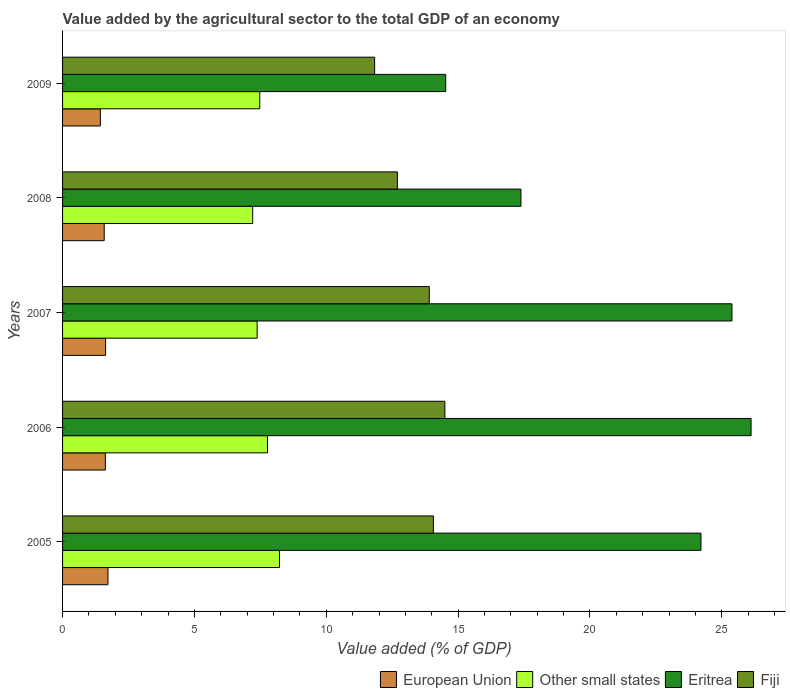What is the value added by the agricultural sector to the total GDP in Fiji in 2005?
Your response must be concise. 14.06. Across all years, what is the maximum value added by the agricultural sector to the total GDP in Eritrea?
Offer a terse response. 26.11. Across all years, what is the minimum value added by the agricultural sector to the total GDP in Eritrea?
Provide a short and direct response. 14.53. In which year was the value added by the agricultural sector to the total GDP in Other small states maximum?
Keep it short and to the point. 2005. What is the total value added by the agricultural sector to the total GDP in Fiji in the graph?
Offer a terse response. 67. What is the difference between the value added by the agricultural sector to the total GDP in Eritrea in 2007 and that in 2008?
Offer a terse response. 8. What is the difference between the value added by the agricultural sector to the total GDP in Fiji in 2006 and the value added by the agricultural sector to the total GDP in Eritrea in 2008?
Offer a terse response. -2.88. What is the average value added by the agricultural sector to the total GDP in Other small states per year?
Your response must be concise. 7.61. In the year 2006, what is the difference between the value added by the agricultural sector to the total GDP in Fiji and value added by the agricultural sector to the total GDP in Eritrea?
Provide a short and direct response. -11.61. What is the ratio of the value added by the agricultural sector to the total GDP in Other small states in 2006 to that in 2008?
Provide a succinct answer. 1.08. What is the difference between the highest and the second highest value added by the agricultural sector to the total GDP in Eritrea?
Offer a very short reply. 0.73. What is the difference between the highest and the lowest value added by the agricultural sector to the total GDP in Fiji?
Your answer should be compact. 2.66. In how many years, is the value added by the agricultural sector to the total GDP in European Union greater than the average value added by the agricultural sector to the total GDP in European Union taken over all years?
Provide a short and direct response. 3. Is the sum of the value added by the agricultural sector to the total GDP in Fiji in 2008 and 2009 greater than the maximum value added by the agricultural sector to the total GDP in European Union across all years?
Offer a very short reply. Yes. What does the 2nd bar from the bottom in 2007 represents?
Make the answer very short. Other small states. Is it the case that in every year, the sum of the value added by the agricultural sector to the total GDP in European Union and value added by the agricultural sector to the total GDP in Other small states is greater than the value added by the agricultural sector to the total GDP in Fiji?
Offer a terse response. No. Are all the bars in the graph horizontal?
Provide a succinct answer. Yes. Does the graph contain any zero values?
Make the answer very short. No. Where does the legend appear in the graph?
Keep it short and to the point. Bottom right. How many legend labels are there?
Your answer should be very brief. 4. What is the title of the graph?
Keep it short and to the point. Value added by the agricultural sector to the total GDP of an economy. What is the label or title of the X-axis?
Your answer should be very brief. Value added (% of GDP). What is the label or title of the Y-axis?
Keep it short and to the point. Years. What is the Value added (% of GDP) in European Union in 2005?
Your answer should be compact. 1.72. What is the Value added (% of GDP) in Other small states in 2005?
Your answer should be very brief. 8.23. What is the Value added (% of GDP) in Eritrea in 2005?
Your answer should be compact. 24.21. What is the Value added (% of GDP) in Fiji in 2005?
Your answer should be very brief. 14.06. What is the Value added (% of GDP) in European Union in 2006?
Give a very brief answer. 1.62. What is the Value added (% of GDP) of Other small states in 2006?
Give a very brief answer. 7.77. What is the Value added (% of GDP) of Eritrea in 2006?
Your answer should be compact. 26.11. What is the Value added (% of GDP) in Fiji in 2006?
Your answer should be very brief. 14.5. What is the Value added (% of GDP) in European Union in 2007?
Offer a very short reply. 1.63. What is the Value added (% of GDP) of Other small states in 2007?
Offer a very short reply. 7.38. What is the Value added (% of GDP) of Eritrea in 2007?
Make the answer very short. 25.38. What is the Value added (% of GDP) in Fiji in 2007?
Give a very brief answer. 13.91. What is the Value added (% of GDP) of European Union in 2008?
Your response must be concise. 1.58. What is the Value added (% of GDP) of Other small states in 2008?
Keep it short and to the point. 7.21. What is the Value added (% of GDP) of Eritrea in 2008?
Ensure brevity in your answer.  17.38. What is the Value added (% of GDP) in Fiji in 2008?
Your response must be concise. 12.7. What is the Value added (% of GDP) in European Union in 2009?
Make the answer very short. 1.43. What is the Value added (% of GDP) in Other small states in 2009?
Offer a terse response. 7.48. What is the Value added (% of GDP) of Eritrea in 2009?
Your answer should be compact. 14.53. What is the Value added (% of GDP) of Fiji in 2009?
Your answer should be compact. 11.83. Across all years, what is the maximum Value added (% of GDP) of European Union?
Provide a succinct answer. 1.72. Across all years, what is the maximum Value added (% of GDP) of Other small states?
Provide a short and direct response. 8.23. Across all years, what is the maximum Value added (% of GDP) in Eritrea?
Give a very brief answer. 26.11. Across all years, what is the maximum Value added (% of GDP) of Fiji?
Offer a terse response. 14.5. Across all years, what is the minimum Value added (% of GDP) in European Union?
Offer a very short reply. 1.43. Across all years, what is the minimum Value added (% of GDP) in Other small states?
Your answer should be very brief. 7.21. Across all years, what is the minimum Value added (% of GDP) in Eritrea?
Ensure brevity in your answer.  14.53. Across all years, what is the minimum Value added (% of GDP) of Fiji?
Offer a terse response. 11.83. What is the total Value added (% of GDP) in European Union in the graph?
Make the answer very short. 7.99. What is the total Value added (% of GDP) of Other small states in the graph?
Provide a short and direct response. 38.06. What is the total Value added (% of GDP) of Eritrea in the graph?
Give a very brief answer. 107.61. What is the total Value added (% of GDP) of Fiji in the graph?
Offer a terse response. 67. What is the difference between the Value added (% of GDP) in European Union in 2005 and that in 2006?
Ensure brevity in your answer.  0.1. What is the difference between the Value added (% of GDP) of Other small states in 2005 and that in 2006?
Offer a terse response. 0.46. What is the difference between the Value added (% of GDP) in Eritrea in 2005 and that in 2006?
Provide a succinct answer. -1.9. What is the difference between the Value added (% of GDP) in Fiji in 2005 and that in 2006?
Your answer should be compact. -0.44. What is the difference between the Value added (% of GDP) of European Union in 2005 and that in 2007?
Ensure brevity in your answer.  0.09. What is the difference between the Value added (% of GDP) of Other small states in 2005 and that in 2007?
Provide a succinct answer. 0.85. What is the difference between the Value added (% of GDP) of Eritrea in 2005 and that in 2007?
Your answer should be compact. -1.17. What is the difference between the Value added (% of GDP) in Fiji in 2005 and that in 2007?
Your answer should be very brief. 0.16. What is the difference between the Value added (% of GDP) of European Union in 2005 and that in 2008?
Offer a very short reply. 0.14. What is the difference between the Value added (% of GDP) in Other small states in 2005 and that in 2008?
Provide a short and direct response. 1.02. What is the difference between the Value added (% of GDP) in Eritrea in 2005 and that in 2008?
Ensure brevity in your answer.  6.83. What is the difference between the Value added (% of GDP) in Fiji in 2005 and that in 2008?
Give a very brief answer. 1.37. What is the difference between the Value added (% of GDP) in European Union in 2005 and that in 2009?
Offer a very short reply. 0.29. What is the difference between the Value added (% of GDP) of Other small states in 2005 and that in 2009?
Make the answer very short. 0.75. What is the difference between the Value added (% of GDP) of Eritrea in 2005 and that in 2009?
Offer a terse response. 9.68. What is the difference between the Value added (% of GDP) in Fiji in 2005 and that in 2009?
Keep it short and to the point. 2.23. What is the difference between the Value added (% of GDP) in European Union in 2006 and that in 2007?
Your answer should be compact. -0.01. What is the difference between the Value added (% of GDP) in Other small states in 2006 and that in 2007?
Give a very brief answer. 0.39. What is the difference between the Value added (% of GDP) in Eritrea in 2006 and that in 2007?
Offer a terse response. 0.73. What is the difference between the Value added (% of GDP) of Fiji in 2006 and that in 2007?
Offer a very short reply. 0.59. What is the difference between the Value added (% of GDP) in European Union in 2006 and that in 2008?
Offer a very short reply. 0.04. What is the difference between the Value added (% of GDP) of Other small states in 2006 and that in 2008?
Make the answer very short. 0.56. What is the difference between the Value added (% of GDP) of Eritrea in 2006 and that in 2008?
Provide a short and direct response. 8.73. What is the difference between the Value added (% of GDP) in Fiji in 2006 and that in 2008?
Provide a short and direct response. 1.8. What is the difference between the Value added (% of GDP) in European Union in 2006 and that in 2009?
Your answer should be very brief. 0.19. What is the difference between the Value added (% of GDP) in Other small states in 2006 and that in 2009?
Give a very brief answer. 0.29. What is the difference between the Value added (% of GDP) in Eritrea in 2006 and that in 2009?
Offer a terse response. 11.58. What is the difference between the Value added (% of GDP) in Fiji in 2006 and that in 2009?
Offer a very short reply. 2.66. What is the difference between the Value added (% of GDP) in European Union in 2007 and that in 2008?
Offer a terse response. 0.05. What is the difference between the Value added (% of GDP) of Other small states in 2007 and that in 2008?
Keep it short and to the point. 0.17. What is the difference between the Value added (% of GDP) in Eritrea in 2007 and that in 2008?
Ensure brevity in your answer.  8. What is the difference between the Value added (% of GDP) of Fiji in 2007 and that in 2008?
Give a very brief answer. 1.21. What is the difference between the Value added (% of GDP) of European Union in 2007 and that in 2009?
Your answer should be compact. 0.2. What is the difference between the Value added (% of GDP) of Other small states in 2007 and that in 2009?
Keep it short and to the point. -0.1. What is the difference between the Value added (% of GDP) of Eritrea in 2007 and that in 2009?
Offer a terse response. 10.85. What is the difference between the Value added (% of GDP) in Fiji in 2007 and that in 2009?
Keep it short and to the point. 2.07. What is the difference between the Value added (% of GDP) of European Union in 2008 and that in 2009?
Ensure brevity in your answer.  0.15. What is the difference between the Value added (% of GDP) in Other small states in 2008 and that in 2009?
Offer a very short reply. -0.27. What is the difference between the Value added (% of GDP) in Eritrea in 2008 and that in 2009?
Provide a succinct answer. 2.85. What is the difference between the Value added (% of GDP) of Fiji in 2008 and that in 2009?
Provide a short and direct response. 0.86. What is the difference between the Value added (% of GDP) of European Union in 2005 and the Value added (% of GDP) of Other small states in 2006?
Keep it short and to the point. -6.05. What is the difference between the Value added (% of GDP) in European Union in 2005 and the Value added (% of GDP) in Eritrea in 2006?
Provide a short and direct response. -24.39. What is the difference between the Value added (% of GDP) in European Union in 2005 and the Value added (% of GDP) in Fiji in 2006?
Keep it short and to the point. -12.78. What is the difference between the Value added (% of GDP) in Other small states in 2005 and the Value added (% of GDP) in Eritrea in 2006?
Provide a succinct answer. -17.88. What is the difference between the Value added (% of GDP) of Other small states in 2005 and the Value added (% of GDP) of Fiji in 2006?
Keep it short and to the point. -6.27. What is the difference between the Value added (% of GDP) in Eritrea in 2005 and the Value added (% of GDP) in Fiji in 2006?
Your answer should be very brief. 9.71. What is the difference between the Value added (% of GDP) of European Union in 2005 and the Value added (% of GDP) of Other small states in 2007?
Ensure brevity in your answer.  -5.66. What is the difference between the Value added (% of GDP) of European Union in 2005 and the Value added (% of GDP) of Eritrea in 2007?
Your answer should be very brief. -23.66. What is the difference between the Value added (% of GDP) in European Union in 2005 and the Value added (% of GDP) in Fiji in 2007?
Ensure brevity in your answer.  -12.19. What is the difference between the Value added (% of GDP) in Other small states in 2005 and the Value added (% of GDP) in Eritrea in 2007?
Provide a short and direct response. -17.16. What is the difference between the Value added (% of GDP) in Other small states in 2005 and the Value added (% of GDP) in Fiji in 2007?
Offer a terse response. -5.68. What is the difference between the Value added (% of GDP) in Eritrea in 2005 and the Value added (% of GDP) in Fiji in 2007?
Your answer should be compact. 10.3. What is the difference between the Value added (% of GDP) of European Union in 2005 and the Value added (% of GDP) of Other small states in 2008?
Give a very brief answer. -5.49. What is the difference between the Value added (% of GDP) in European Union in 2005 and the Value added (% of GDP) in Eritrea in 2008?
Your answer should be very brief. -15.66. What is the difference between the Value added (% of GDP) of European Union in 2005 and the Value added (% of GDP) of Fiji in 2008?
Your response must be concise. -10.98. What is the difference between the Value added (% of GDP) of Other small states in 2005 and the Value added (% of GDP) of Eritrea in 2008?
Offer a very short reply. -9.15. What is the difference between the Value added (% of GDP) in Other small states in 2005 and the Value added (% of GDP) in Fiji in 2008?
Keep it short and to the point. -4.47. What is the difference between the Value added (% of GDP) in Eritrea in 2005 and the Value added (% of GDP) in Fiji in 2008?
Provide a succinct answer. 11.51. What is the difference between the Value added (% of GDP) in European Union in 2005 and the Value added (% of GDP) in Other small states in 2009?
Offer a very short reply. -5.76. What is the difference between the Value added (% of GDP) of European Union in 2005 and the Value added (% of GDP) of Eritrea in 2009?
Provide a short and direct response. -12.81. What is the difference between the Value added (% of GDP) in European Union in 2005 and the Value added (% of GDP) in Fiji in 2009?
Keep it short and to the point. -10.11. What is the difference between the Value added (% of GDP) of Other small states in 2005 and the Value added (% of GDP) of Eritrea in 2009?
Offer a very short reply. -6.3. What is the difference between the Value added (% of GDP) in Other small states in 2005 and the Value added (% of GDP) in Fiji in 2009?
Give a very brief answer. -3.61. What is the difference between the Value added (% of GDP) in Eritrea in 2005 and the Value added (% of GDP) in Fiji in 2009?
Make the answer very short. 12.38. What is the difference between the Value added (% of GDP) of European Union in 2006 and the Value added (% of GDP) of Other small states in 2007?
Give a very brief answer. -5.76. What is the difference between the Value added (% of GDP) of European Union in 2006 and the Value added (% of GDP) of Eritrea in 2007?
Offer a terse response. -23.76. What is the difference between the Value added (% of GDP) of European Union in 2006 and the Value added (% of GDP) of Fiji in 2007?
Make the answer very short. -12.28. What is the difference between the Value added (% of GDP) in Other small states in 2006 and the Value added (% of GDP) in Eritrea in 2007?
Offer a very short reply. -17.61. What is the difference between the Value added (% of GDP) in Other small states in 2006 and the Value added (% of GDP) in Fiji in 2007?
Ensure brevity in your answer.  -6.14. What is the difference between the Value added (% of GDP) of Eritrea in 2006 and the Value added (% of GDP) of Fiji in 2007?
Your answer should be very brief. 12.2. What is the difference between the Value added (% of GDP) of European Union in 2006 and the Value added (% of GDP) of Other small states in 2008?
Offer a very short reply. -5.59. What is the difference between the Value added (% of GDP) in European Union in 2006 and the Value added (% of GDP) in Eritrea in 2008?
Make the answer very short. -15.76. What is the difference between the Value added (% of GDP) of European Union in 2006 and the Value added (% of GDP) of Fiji in 2008?
Offer a terse response. -11.08. What is the difference between the Value added (% of GDP) in Other small states in 2006 and the Value added (% of GDP) in Eritrea in 2008?
Your answer should be compact. -9.61. What is the difference between the Value added (% of GDP) of Other small states in 2006 and the Value added (% of GDP) of Fiji in 2008?
Make the answer very short. -4.93. What is the difference between the Value added (% of GDP) in Eritrea in 2006 and the Value added (% of GDP) in Fiji in 2008?
Offer a terse response. 13.41. What is the difference between the Value added (% of GDP) of European Union in 2006 and the Value added (% of GDP) of Other small states in 2009?
Offer a very short reply. -5.86. What is the difference between the Value added (% of GDP) in European Union in 2006 and the Value added (% of GDP) in Eritrea in 2009?
Provide a short and direct response. -12.91. What is the difference between the Value added (% of GDP) in European Union in 2006 and the Value added (% of GDP) in Fiji in 2009?
Keep it short and to the point. -10.21. What is the difference between the Value added (% of GDP) in Other small states in 2006 and the Value added (% of GDP) in Eritrea in 2009?
Your answer should be compact. -6.76. What is the difference between the Value added (% of GDP) of Other small states in 2006 and the Value added (% of GDP) of Fiji in 2009?
Ensure brevity in your answer.  -4.06. What is the difference between the Value added (% of GDP) of Eritrea in 2006 and the Value added (% of GDP) of Fiji in 2009?
Keep it short and to the point. 14.27. What is the difference between the Value added (% of GDP) in European Union in 2007 and the Value added (% of GDP) in Other small states in 2008?
Make the answer very short. -5.58. What is the difference between the Value added (% of GDP) in European Union in 2007 and the Value added (% of GDP) in Eritrea in 2008?
Offer a very short reply. -15.75. What is the difference between the Value added (% of GDP) in European Union in 2007 and the Value added (% of GDP) in Fiji in 2008?
Your answer should be compact. -11.07. What is the difference between the Value added (% of GDP) in Other small states in 2007 and the Value added (% of GDP) in Eritrea in 2008?
Provide a short and direct response. -10. What is the difference between the Value added (% of GDP) in Other small states in 2007 and the Value added (% of GDP) in Fiji in 2008?
Ensure brevity in your answer.  -5.32. What is the difference between the Value added (% of GDP) of Eritrea in 2007 and the Value added (% of GDP) of Fiji in 2008?
Make the answer very short. 12.69. What is the difference between the Value added (% of GDP) in European Union in 2007 and the Value added (% of GDP) in Other small states in 2009?
Provide a short and direct response. -5.85. What is the difference between the Value added (% of GDP) in European Union in 2007 and the Value added (% of GDP) in Eritrea in 2009?
Provide a short and direct response. -12.9. What is the difference between the Value added (% of GDP) of European Union in 2007 and the Value added (% of GDP) of Fiji in 2009?
Make the answer very short. -10.2. What is the difference between the Value added (% of GDP) of Other small states in 2007 and the Value added (% of GDP) of Eritrea in 2009?
Provide a succinct answer. -7.15. What is the difference between the Value added (% of GDP) in Other small states in 2007 and the Value added (% of GDP) in Fiji in 2009?
Your response must be concise. -4.45. What is the difference between the Value added (% of GDP) of Eritrea in 2007 and the Value added (% of GDP) of Fiji in 2009?
Keep it short and to the point. 13.55. What is the difference between the Value added (% of GDP) in European Union in 2008 and the Value added (% of GDP) in Other small states in 2009?
Provide a short and direct response. -5.9. What is the difference between the Value added (% of GDP) in European Union in 2008 and the Value added (% of GDP) in Eritrea in 2009?
Give a very brief answer. -12.95. What is the difference between the Value added (% of GDP) of European Union in 2008 and the Value added (% of GDP) of Fiji in 2009?
Your answer should be very brief. -10.25. What is the difference between the Value added (% of GDP) of Other small states in 2008 and the Value added (% of GDP) of Eritrea in 2009?
Make the answer very short. -7.32. What is the difference between the Value added (% of GDP) of Other small states in 2008 and the Value added (% of GDP) of Fiji in 2009?
Your response must be concise. -4.62. What is the difference between the Value added (% of GDP) in Eritrea in 2008 and the Value added (% of GDP) in Fiji in 2009?
Your answer should be very brief. 5.55. What is the average Value added (% of GDP) of European Union per year?
Your response must be concise. 1.6. What is the average Value added (% of GDP) in Other small states per year?
Offer a terse response. 7.61. What is the average Value added (% of GDP) in Eritrea per year?
Your answer should be very brief. 21.52. What is the average Value added (% of GDP) in Fiji per year?
Provide a succinct answer. 13.4. In the year 2005, what is the difference between the Value added (% of GDP) of European Union and Value added (% of GDP) of Other small states?
Ensure brevity in your answer.  -6.51. In the year 2005, what is the difference between the Value added (% of GDP) in European Union and Value added (% of GDP) in Eritrea?
Give a very brief answer. -22.49. In the year 2005, what is the difference between the Value added (% of GDP) in European Union and Value added (% of GDP) in Fiji?
Your answer should be compact. -12.34. In the year 2005, what is the difference between the Value added (% of GDP) in Other small states and Value added (% of GDP) in Eritrea?
Ensure brevity in your answer.  -15.98. In the year 2005, what is the difference between the Value added (% of GDP) of Other small states and Value added (% of GDP) of Fiji?
Your answer should be compact. -5.84. In the year 2005, what is the difference between the Value added (% of GDP) in Eritrea and Value added (% of GDP) in Fiji?
Ensure brevity in your answer.  10.15. In the year 2006, what is the difference between the Value added (% of GDP) in European Union and Value added (% of GDP) in Other small states?
Offer a very short reply. -6.15. In the year 2006, what is the difference between the Value added (% of GDP) of European Union and Value added (% of GDP) of Eritrea?
Your answer should be very brief. -24.49. In the year 2006, what is the difference between the Value added (% of GDP) in European Union and Value added (% of GDP) in Fiji?
Your response must be concise. -12.88. In the year 2006, what is the difference between the Value added (% of GDP) in Other small states and Value added (% of GDP) in Eritrea?
Ensure brevity in your answer.  -18.34. In the year 2006, what is the difference between the Value added (% of GDP) of Other small states and Value added (% of GDP) of Fiji?
Provide a short and direct response. -6.73. In the year 2006, what is the difference between the Value added (% of GDP) in Eritrea and Value added (% of GDP) in Fiji?
Ensure brevity in your answer.  11.61. In the year 2007, what is the difference between the Value added (% of GDP) in European Union and Value added (% of GDP) in Other small states?
Your answer should be compact. -5.75. In the year 2007, what is the difference between the Value added (% of GDP) in European Union and Value added (% of GDP) in Eritrea?
Make the answer very short. -23.75. In the year 2007, what is the difference between the Value added (% of GDP) of European Union and Value added (% of GDP) of Fiji?
Give a very brief answer. -12.28. In the year 2007, what is the difference between the Value added (% of GDP) of Other small states and Value added (% of GDP) of Eritrea?
Your answer should be very brief. -18. In the year 2007, what is the difference between the Value added (% of GDP) in Other small states and Value added (% of GDP) in Fiji?
Provide a short and direct response. -6.53. In the year 2007, what is the difference between the Value added (% of GDP) of Eritrea and Value added (% of GDP) of Fiji?
Your response must be concise. 11.48. In the year 2008, what is the difference between the Value added (% of GDP) in European Union and Value added (% of GDP) in Other small states?
Give a very brief answer. -5.63. In the year 2008, what is the difference between the Value added (% of GDP) in European Union and Value added (% of GDP) in Eritrea?
Your answer should be very brief. -15.8. In the year 2008, what is the difference between the Value added (% of GDP) of European Union and Value added (% of GDP) of Fiji?
Ensure brevity in your answer.  -11.12. In the year 2008, what is the difference between the Value added (% of GDP) in Other small states and Value added (% of GDP) in Eritrea?
Make the answer very short. -10.17. In the year 2008, what is the difference between the Value added (% of GDP) in Other small states and Value added (% of GDP) in Fiji?
Offer a terse response. -5.49. In the year 2008, what is the difference between the Value added (% of GDP) of Eritrea and Value added (% of GDP) of Fiji?
Offer a terse response. 4.69. In the year 2009, what is the difference between the Value added (% of GDP) in European Union and Value added (% of GDP) in Other small states?
Keep it short and to the point. -6.05. In the year 2009, what is the difference between the Value added (% of GDP) of European Union and Value added (% of GDP) of Eritrea?
Offer a very short reply. -13.1. In the year 2009, what is the difference between the Value added (% of GDP) in European Union and Value added (% of GDP) in Fiji?
Offer a terse response. -10.4. In the year 2009, what is the difference between the Value added (% of GDP) in Other small states and Value added (% of GDP) in Eritrea?
Offer a terse response. -7.05. In the year 2009, what is the difference between the Value added (% of GDP) in Other small states and Value added (% of GDP) in Fiji?
Offer a very short reply. -4.36. In the year 2009, what is the difference between the Value added (% of GDP) of Eritrea and Value added (% of GDP) of Fiji?
Your answer should be compact. 2.69. What is the ratio of the Value added (% of GDP) in European Union in 2005 to that in 2006?
Make the answer very short. 1.06. What is the ratio of the Value added (% of GDP) of Other small states in 2005 to that in 2006?
Your answer should be very brief. 1.06. What is the ratio of the Value added (% of GDP) of Eritrea in 2005 to that in 2006?
Give a very brief answer. 0.93. What is the ratio of the Value added (% of GDP) of European Union in 2005 to that in 2007?
Provide a short and direct response. 1.05. What is the ratio of the Value added (% of GDP) in Other small states in 2005 to that in 2007?
Make the answer very short. 1.11. What is the ratio of the Value added (% of GDP) of Eritrea in 2005 to that in 2007?
Ensure brevity in your answer.  0.95. What is the ratio of the Value added (% of GDP) of Fiji in 2005 to that in 2007?
Your answer should be very brief. 1.01. What is the ratio of the Value added (% of GDP) of European Union in 2005 to that in 2008?
Provide a short and direct response. 1.09. What is the ratio of the Value added (% of GDP) of Other small states in 2005 to that in 2008?
Provide a succinct answer. 1.14. What is the ratio of the Value added (% of GDP) in Eritrea in 2005 to that in 2008?
Offer a terse response. 1.39. What is the ratio of the Value added (% of GDP) of Fiji in 2005 to that in 2008?
Ensure brevity in your answer.  1.11. What is the ratio of the Value added (% of GDP) in European Union in 2005 to that in 2009?
Offer a very short reply. 1.2. What is the ratio of the Value added (% of GDP) of Other small states in 2005 to that in 2009?
Your response must be concise. 1.1. What is the ratio of the Value added (% of GDP) of Eritrea in 2005 to that in 2009?
Keep it short and to the point. 1.67. What is the ratio of the Value added (% of GDP) of Fiji in 2005 to that in 2009?
Your response must be concise. 1.19. What is the ratio of the Value added (% of GDP) of European Union in 2006 to that in 2007?
Offer a very short reply. 0.99. What is the ratio of the Value added (% of GDP) of Other small states in 2006 to that in 2007?
Provide a short and direct response. 1.05. What is the ratio of the Value added (% of GDP) in Eritrea in 2006 to that in 2007?
Provide a short and direct response. 1.03. What is the ratio of the Value added (% of GDP) of Fiji in 2006 to that in 2007?
Your response must be concise. 1.04. What is the ratio of the Value added (% of GDP) in European Union in 2006 to that in 2008?
Provide a succinct answer. 1.03. What is the ratio of the Value added (% of GDP) of Other small states in 2006 to that in 2008?
Offer a terse response. 1.08. What is the ratio of the Value added (% of GDP) in Eritrea in 2006 to that in 2008?
Your answer should be compact. 1.5. What is the ratio of the Value added (% of GDP) of Fiji in 2006 to that in 2008?
Give a very brief answer. 1.14. What is the ratio of the Value added (% of GDP) in European Union in 2006 to that in 2009?
Offer a very short reply. 1.13. What is the ratio of the Value added (% of GDP) in Other small states in 2006 to that in 2009?
Your response must be concise. 1.04. What is the ratio of the Value added (% of GDP) of Eritrea in 2006 to that in 2009?
Make the answer very short. 1.8. What is the ratio of the Value added (% of GDP) of Fiji in 2006 to that in 2009?
Your answer should be very brief. 1.23. What is the ratio of the Value added (% of GDP) of European Union in 2007 to that in 2008?
Give a very brief answer. 1.03. What is the ratio of the Value added (% of GDP) in Other small states in 2007 to that in 2008?
Provide a succinct answer. 1.02. What is the ratio of the Value added (% of GDP) of Eritrea in 2007 to that in 2008?
Your response must be concise. 1.46. What is the ratio of the Value added (% of GDP) in Fiji in 2007 to that in 2008?
Ensure brevity in your answer.  1.1. What is the ratio of the Value added (% of GDP) of European Union in 2007 to that in 2009?
Offer a very short reply. 1.14. What is the ratio of the Value added (% of GDP) of Other small states in 2007 to that in 2009?
Make the answer very short. 0.99. What is the ratio of the Value added (% of GDP) of Eritrea in 2007 to that in 2009?
Provide a short and direct response. 1.75. What is the ratio of the Value added (% of GDP) in Fiji in 2007 to that in 2009?
Provide a succinct answer. 1.18. What is the ratio of the Value added (% of GDP) in European Union in 2008 to that in 2009?
Ensure brevity in your answer.  1.1. What is the ratio of the Value added (% of GDP) in Other small states in 2008 to that in 2009?
Ensure brevity in your answer.  0.96. What is the ratio of the Value added (% of GDP) in Eritrea in 2008 to that in 2009?
Offer a terse response. 1.2. What is the ratio of the Value added (% of GDP) in Fiji in 2008 to that in 2009?
Make the answer very short. 1.07. What is the difference between the highest and the second highest Value added (% of GDP) of European Union?
Give a very brief answer. 0.09. What is the difference between the highest and the second highest Value added (% of GDP) of Other small states?
Your answer should be compact. 0.46. What is the difference between the highest and the second highest Value added (% of GDP) of Eritrea?
Offer a terse response. 0.73. What is the difference between the highest and the second highest Value added (% of GDP) of Fiji?
Offer a terse response. 0.44. What is the difference between the highest and the lowest Value added (% of GDP) in European Union?
Offer a terse response. 0.29. What is the difference between the highest and the lowest Value added (% of GDP) in Other small states?
Provide a short and direct response. 1.02. What is the difference between the highest and the lowest Value added (% of GDP) in Eritrea?
Offer a terse response. 11.58. What is the difference between the highest and the lowest Value added (% of GDP) in Fiji?
Your answer should be very brief. 2.66. 